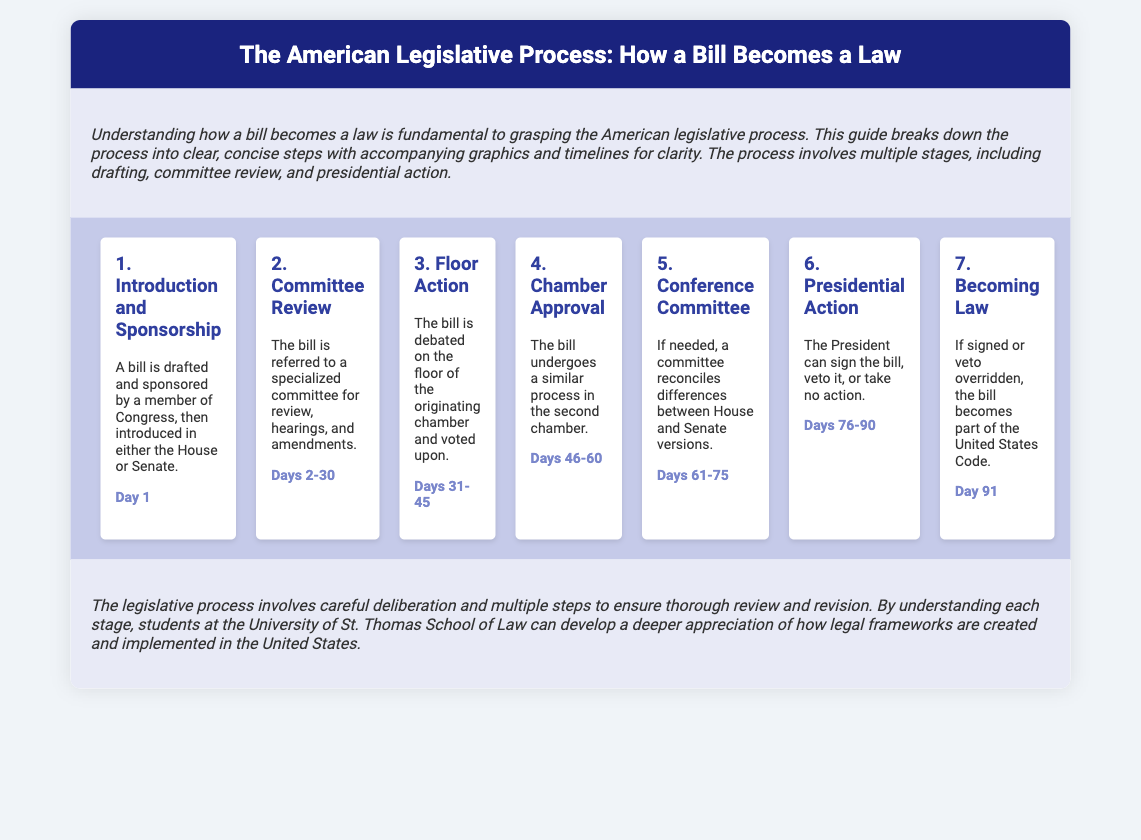What is the first step in the legislative process? The first step is the introduction and sponsorship, where a bill is drafted and sponsored by a member of Congress.
Answer: Introduction and Sponsorship How many days are allocated for committee review? The timeline indicates that the committee review takes from Day 2 to Day 30.
Answer: Days 2-30 What action can the President take regarding a bill? The President can sign the bill, veto it, or take no action.
Answer: Sign, veto, or take no action What happens to the bill after it is signed or if a veto is overridden? If signed or veto overridden, the bill becomes part of the United States Code.
Answer: Becomes part of the United States Code What is the total duration of the legislative process as per the timeline? The process spans from Day 1 to Day 91, indicating a total duration of 91 days.
Answer: 91 days Which chamber must approve the bill after the floor action? After floor action, the bill undergoes a similar process in the second chamber.
Answer: Second chamber What is the purpose of the conference committee? A conference committee reconciles differences between House and Senate versions if needed.
Answer: Reconcile differences What is indicated in the conclusion about the legislative process? The conclusion notes that the legislative process involves careful deliberation and multiple steps to ensure thorough review and revision.
Answer: Careful deliberation and multiple steps 